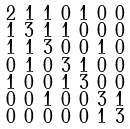Convert formula to latex. <formula><loc_0><loc_0><loc_500><loc_500>\begin{smallmatrix} 2 & 1 & 1 & 0 & 1 & 0 & 0 \\ 1 & 3 & 1 & 1 & 0 & 0 & 0 \\ 1 & 1 & 3 & 0 & 0 & 1 & 0 \\ 0 & 1 & 0 & 3 & 1 & 0 & 0 \\ 1 & 0 & 0 & 1 & 3 & 0 & 0 \\ 0 & 0 & 1 & 0 & 0 & 3 & 1 \\ 0 & 0 & 0 & 0 & 0 & 1 & 3 \end{smallmatrix}</formula> 